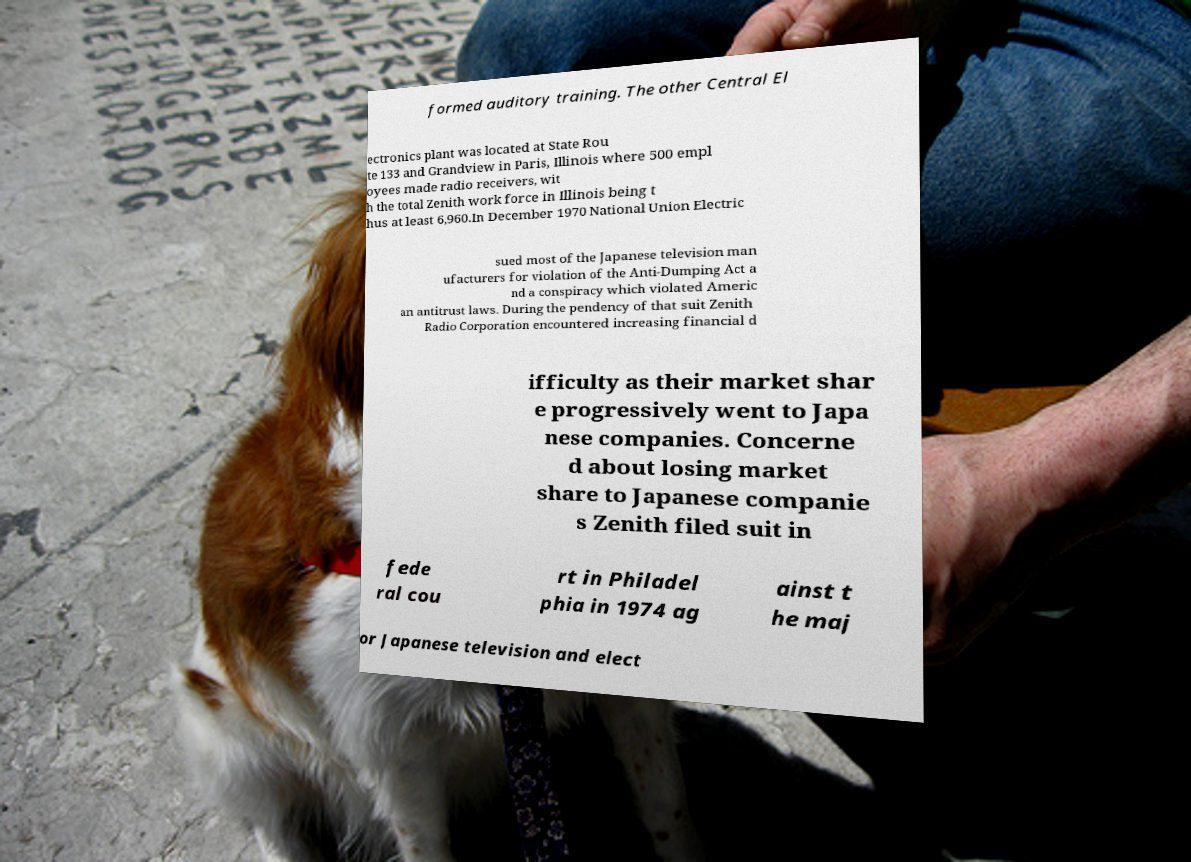Please read and relay the text visible in this image. What does it say? formed auditory training. The other Central El ectronics plant was located at State Rou te 133 and Grandview in Paris, Illinois where 500 empl oyees made radio receivers, wit h the total Zenith work force in Illinois being t hus at least 6,960.In December 1970 National Union Electric sued most of the Japanese television man ufacturers for violation of the Anti-Dumping Act a nd a conspiracy which violated Americ an antitrust laws. During the pendency of that suit Zenith Radio Corporation encountered increasing financial d ifficulty as their market shar e progressively went to Japa nese companies. Concerne d about losing market share to Japanese companie s Zenith filed suit in fede ral cou rt in Philadel phia in 1974 ag ainst t he maj or Japanese television and elect 